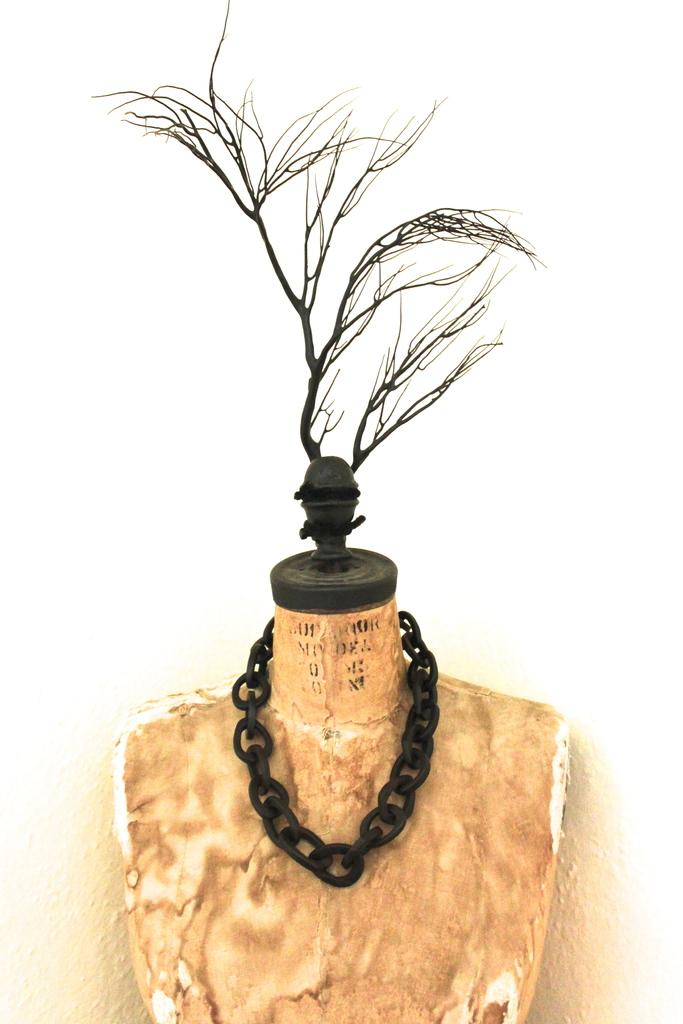What type of tree is present in the image? There is a plastic tree in the image. What other object can be seen in the image? There is a black color chain in the image. Is there any text present in the image? Yes, there is text written in the image. What is the color of the background in the image? The background of the image is white. Can you see a wheel attached to the plastic tree in the image? No, there is no wheel attached to the plastic tree in the image. 